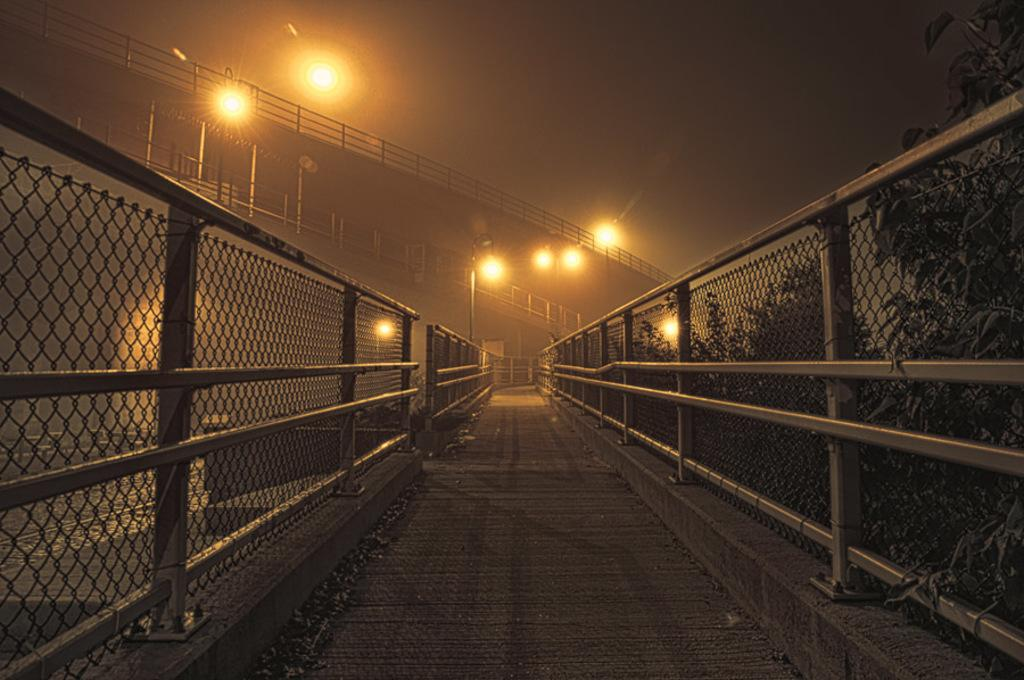What is the main feature of the image? There is a road in the image. What type of fencing is present along the road? The road has fencing with rods. What can be seen on the right side of the image? There are trees on the right side of the image. What structures are visible in the background of the image? There are light poles and bridges with railings in the background of the image. What type of mist is covering the road in the image? There is no mist present in the image; the road is clearly visible. Who is the achiever mentioned in the image? There is no mention of an achiever in the image. 